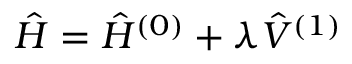Convert formula to latex. <formula><loc_0><loc_0><loc_500><loc_500>\hat { H } = \hat { H } ^ { ( 0 ) } + \lambda \hat { V } ^ { ( 1 ) }</formula> 